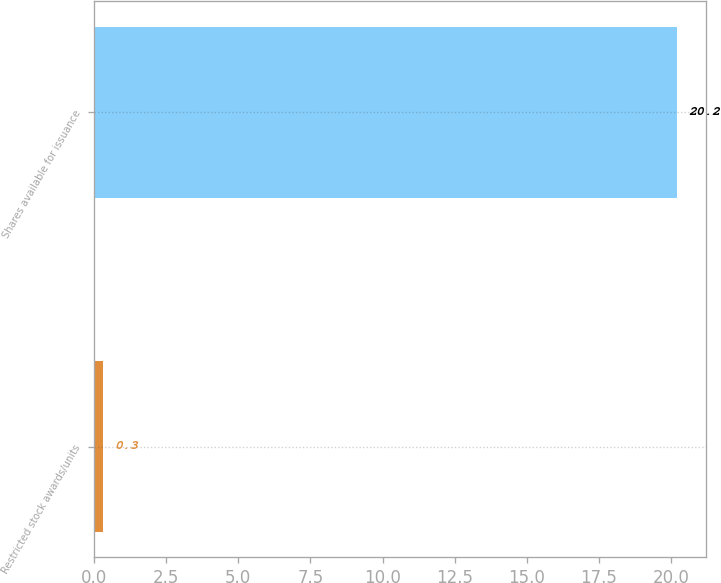Convert chart. <chart><loc_0><loc_0><loc_500><loc_500><bar_chart><fcel>Restricted stock awards/units<fcel>Shares available for issuance<nl><fcel>0.3<fcel>20.2<nl></chart> 